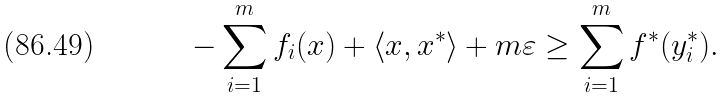<formula> <loc_0><loc_0><loc_500><loc_500>- \sum _ { i = 1 } ^ { m } f _ { i } ( x ) + \langle x , x ^ { * } \rangle + m \varepsilon \geq \sum _ { i = 1 } ^ { m } f ^ { * } ( y _ { i } ^ { * } ) .</formula> 